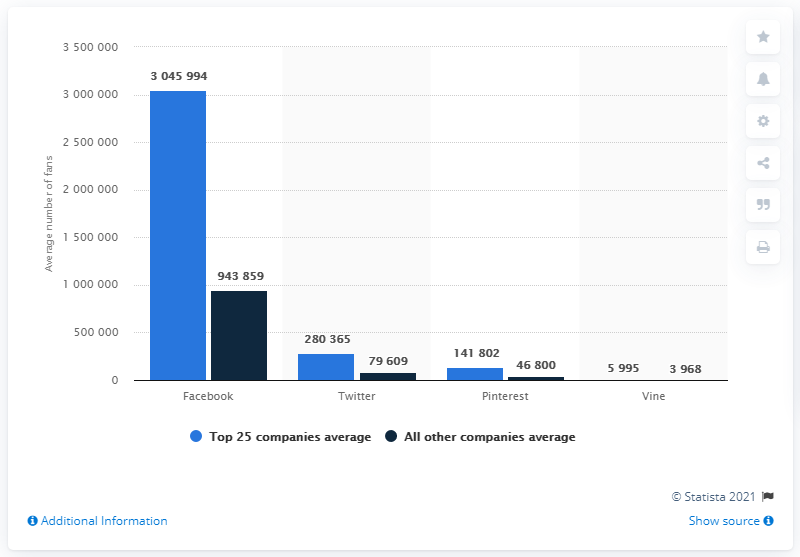Draw attention to some important aspects in this diagram. The average number of Facebook fans was approximately 30,459,940. 